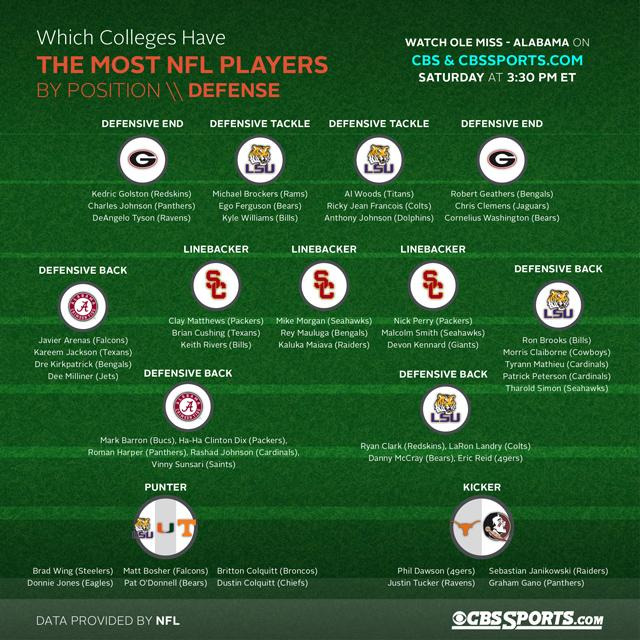Give some essential details in this illustration. The defensive ends from Alabama, Georgia, and Louisiana are from Georgia. Sebastian Janikowski, a college football player known for his ability to kick field goals, attended Florida State University, where he played for the team. The second linebacker who plays in the center belongs to the Cincinnati Bengals. The third linebacker who plays on the left belongs to the Bills. The second defensive end playing on the right side is Chris Clemens. 